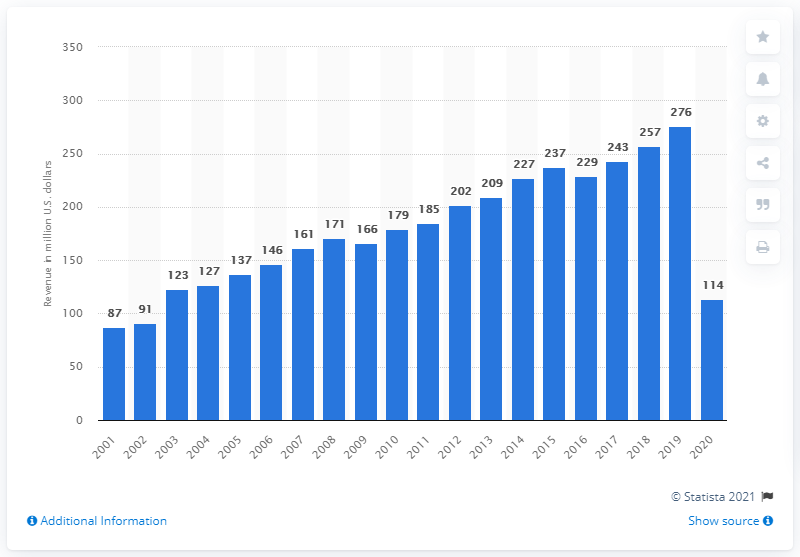Indicate a few pertinent items in this graphic. In 2020, the revenue of the Cincinnati Reds was reported to be $114 million. 